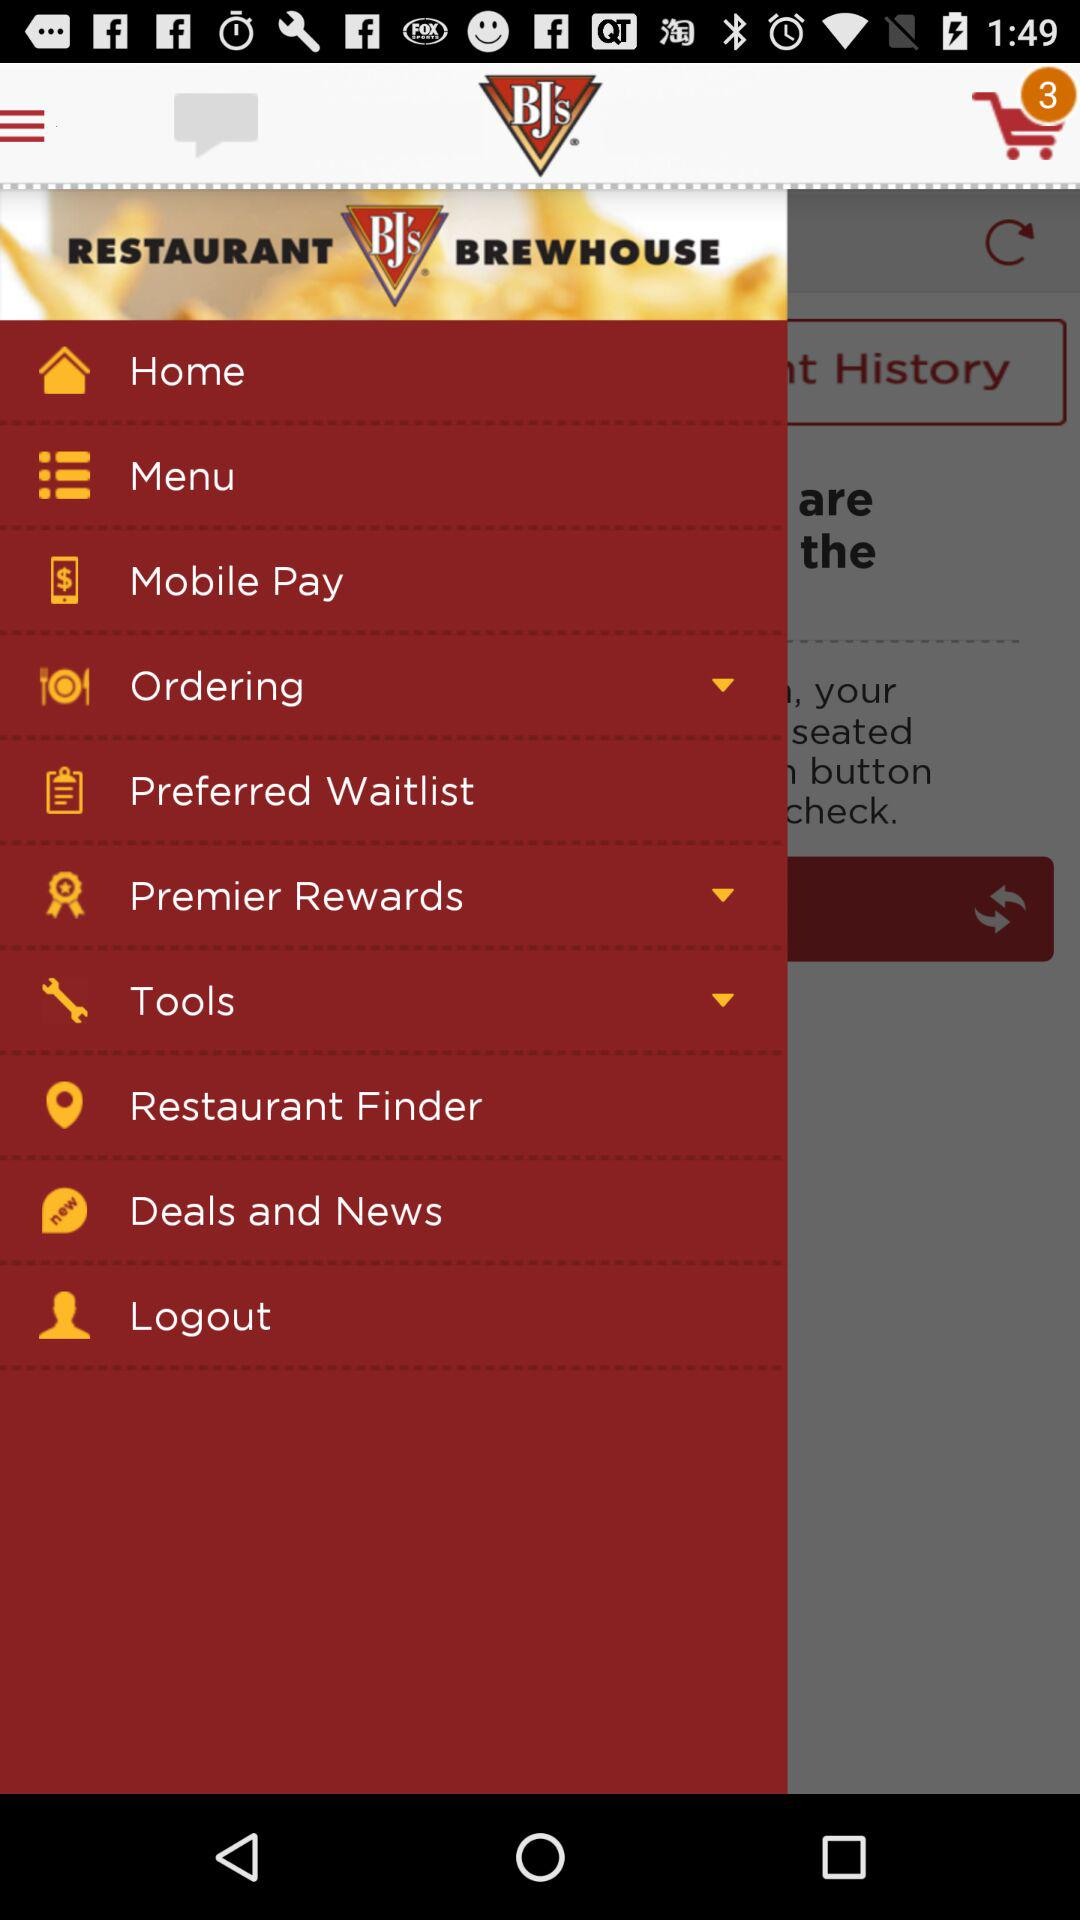How many items are there in the cart? There are 3 items in the cart. 